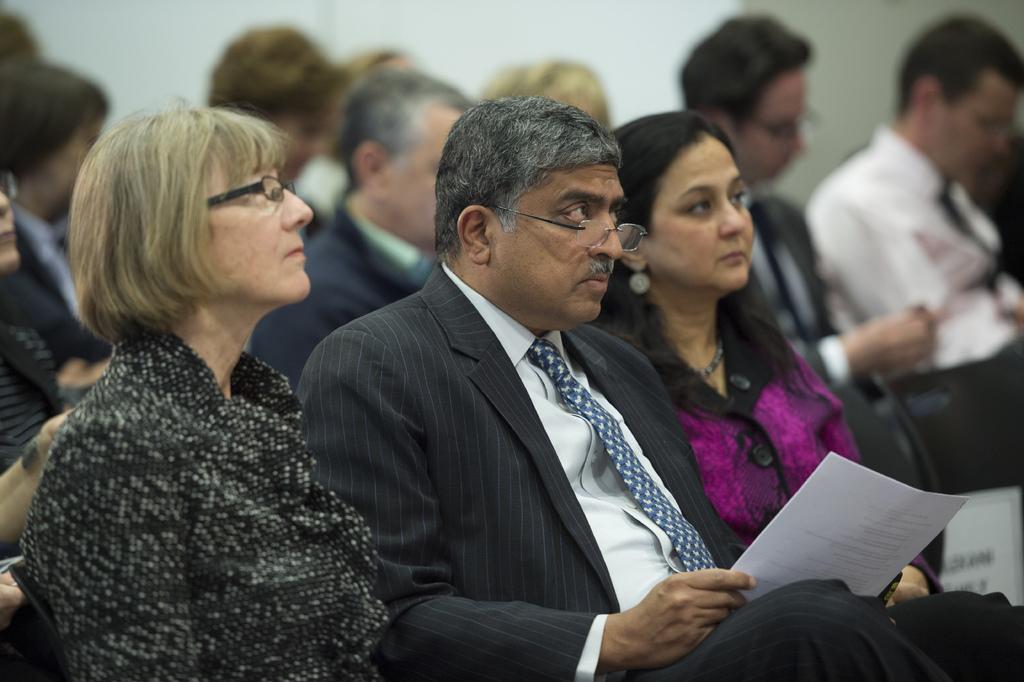In one or two sentences, can you explain what this image depicts? In the foreground of this image, there are two women and a man wearing suit is holding papers in his hands and they three are sitting on the chairs. In the background, there are persons sitting and a white wall. 